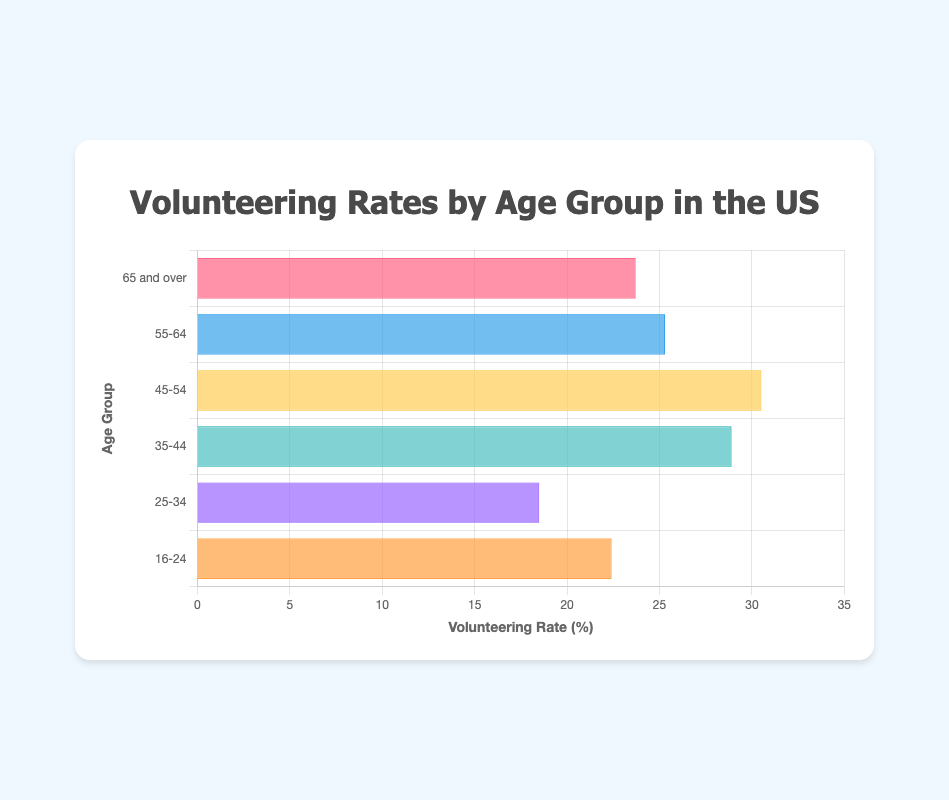What age group has the highest volunteering rate? To find the highest volunteering rate, look at the length of the bars and identify the one that is the longest. The longest bar corresponds to the age group 45-54, with a volunteering rate of 30.5%.
Answer: 45-54 Which two age groups have the closest volunteering rates? Visually inspect the bars to see which are approximately the same length. The bars for the age groups 16-24 and 65 and over are very close in length, with volunteering rates of 22.4% and 23.7% respectively.
Answer: 16-24 and 65 and over What is the difference in the volunteering rates between the age groups 35-44 and 55-64? Identify the two bars corresponding to the age groups 35-44 and 55-64. The rates are 28.9% and 25.3% respectively. Subtract the smaller rate from the larger rate: 28.9% - 25.3% = 3.6%.
Answer: 3.6% What is the average volunteering rate across all age groups? To calculate the average, sum all the volunteering rates and divide by the number of age groups. The rates are 22.4%, 18.5%, 28.9%, 30.5%, 25.3%, and 23.7%. Sum = 149.3%. There are 6 age groups. Average = 149.3% / 6 = 24.88%.
Answer: 24.88% Which age group has the lowest volunteering rate? To find the lowest volunteering rate, look for the shortest bar. The shortest bar is for the age group 25-34, with a volunteering rate of 18.5%.
Answer: 25-34 What is the total volunteering rate for the age groups under 35? Add the volunteering rates for the age groups 16-24 and 25-34. The rates are 22.4% and 18.5%. Sum = 22.4% + 18.5% = 40.9%.
Answer: 40.9% By how much does the volunteering rate for the age group 45-54 exceed the average rate of the shown age groups? First, calculate the average rate (24.88%). The rate for the age group 45-54 is 30.5%. Subtract the average from this rate: 30.5% - 24.88% = 5.62%.
Answer: 5.62% Between which age groups does the volunteering rate increase the most? Compare the differences between consecutive age groups: 25-34 increases to 35-44 by 10.4% (28.9% - 18.5%) which is the largest increase.
Answer: 25-34 to 35-44 What is the median volunteering rate of the age groups? Arrange the rates in ascending order: 18.5%, 22.4%, 23.7%, 25.3%, 28.9%, 30.5%. There are 6 data points. The median is the average of the 3rd and 4th values: (23.7 + 25.3) / 2 = 24.5%.
Answer: 24.5% What are the three age groups with the highest volunteering rates? By visually inspecting the lengths of the bars, the three longest bars are for the age groups 45-54, 35-44, and 55-64 in descending order of length.
Answer: 45-54, 35-44, 55-64 